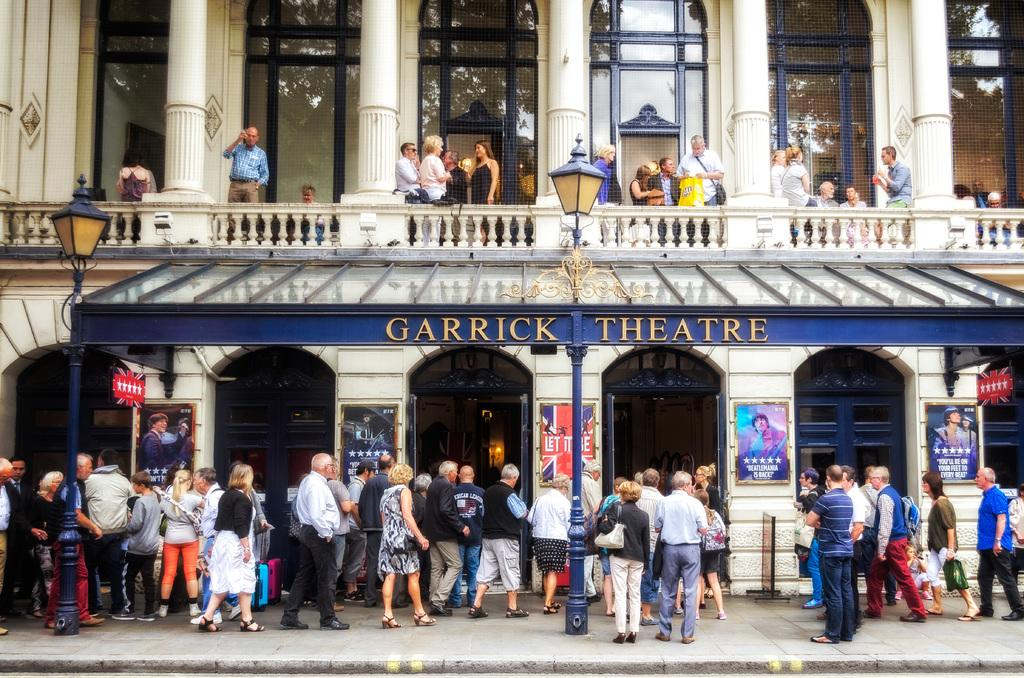How many people are in the image? There are many people in the image. Where are the people located in relation to the Garrick Theater? The people are standing near the Garrick Theater. What can be seen on the left side of the image? There is a pole on the left side of the image. What type of insurance policy do the people in the image have? There is no information about insurance policies in the image. Can you see any bats flying around in the image? There are no bats visible in the image. 